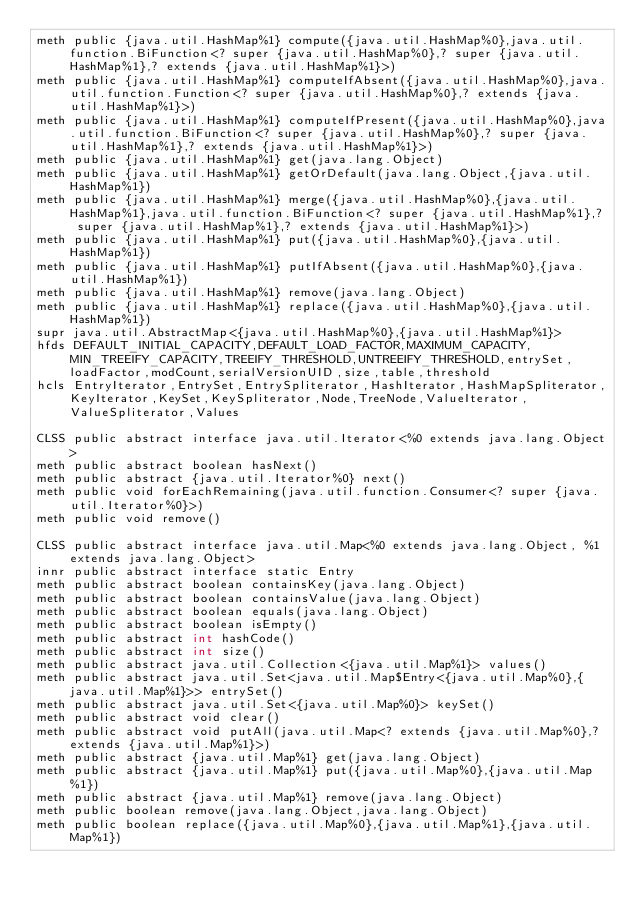<code> <loc_0><loc_0><loc_500><loc_500><_SML_>meth public {java.util.HashMap%1} compute({java.util.HashMap%0},java.util.function.BiFunction<? super {java.util.HashMap%0},? super {java.util.HashMap%1},? extends {java.util.HashMap%1}>)
meth public {java.util.HashMap%1} computeIfAbsent({java.util.HashMap%0},java.util.function.Function<? super {java.util.HashMap%0},? extends {java.util.HashMap%1}>)
meth public {java.util.HashMap%1} computeIfPresent({java.util.HashMap%0},java.util.function.BiFunction<? super {java.util.HashMap%0},? super {java.util.HashMap%1},? extends {java.util.HashMap%1}>)
meth public {java.util.HashMap%1} get(java.lang.Object)
meth public {java.util.HashMap%1} getOrDefault(java.lang.Object,{java.util.HashMap%1})
meth public {java.util.HashMap%1} merge({java.util.HashMap%0},{java.util.HashMap%1},java.util.function.BiFunction<? super {java.util.HashMap%1},? super {java.util.HashMap%1},? extends {java.util.HashMap%1}>)
meth public {java.util.HashMap%1} put({java.util.HashMap%0},{java.util.HashMap%1})
meth public {java.util.HashMap%1} putIfAbsent({java.util.HashMap%0},{java.util.HashMap%1})
meth public {java.util.HashMap%1} remove(java.lang.Object)
meth public {java.util.HashMap%1} replace({java.util.HashMap%0},{java.util.HashMap%1})
supr java.util.AbstractMap<{java.util.HashMap%0},{java.util.HashMap%1}>
hfds DEFAULT_INITIAL_CAPACITY,DEFAULT_LOAD_FACTOR,MAXIMUM_CAPACITY,MIN_TREEIFY_CAPACITY,TREEIFY_THRESHOLD,UNTREEIFY_THRESHOLD,entrySet,loadFactor,modCount,serialVersionUID,size,table,threshold
hcls EntryIterator,EntrySet,EntrySpliterator,HashIterator,HashMapSpliterator,KeyIterator,KeySet,KeySpliterator,Node,TreeNode,ValueIterator,ValueSpliterator,Values

CLSS public abstract interface java.util.Iterator<%0 extends java.lang.Object>
meth public abstract boolean hasNext()
meth public abstract {java.util.Iterator%0} next()
meth public void forEachRemaining(java.util.function.Consumer<? super {java.util.Iterator%0}>)
meth public void remove()

CLSS public abstract interface java.util.Map<%0 extends java.lang.Object, %1 extends java.lang.Object>
innr public abstract interface static Entry
meth public abstract boolean containsKey(java.lang.Object)
meth public abstract boolean containsValue(java.lang.Object)
meth public abstract boolean equals(java.lang.Object)
meth public abstract boolean isEmpty()
meth public abstract int hashCode()
meth public abstract int size()
meth public abstract java.util.Collection<{java.util.Map%1}> values()
meth public abstract java.util.Set<java.util.Map$Entry<{java.util.Map%0},{java.util.Map%1}>> entrySet()
meth public abstract java.util.Set<{java.util.Map%0}> keySet()
meth public abstract void clear()
meth public abstract void putAll(java.util.Map<? extends {java.util.Map%0},? extends {java.util.Map%1}>)
meth public abstract {java.util.Map%1} get(java.lang.Object)
meth public abstract {java.util.Map%1} put({java.util.Map%0},{java.util.Map%1})
meth public abstract {java.util.Map%1} remove(java.lang.Object)
meth public boolean remove(java.lang.Object,java.lang.Object)
meth public boolean replace({java.util.Map%0},{java.util.Map%1},{java.util.Map%1})</code> 